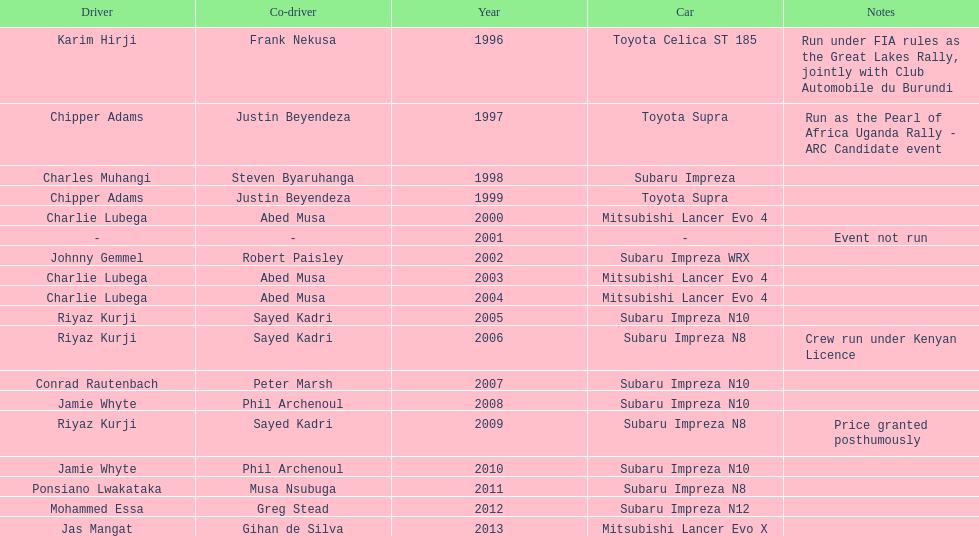How many times was charlie lubega a driver? 3. 